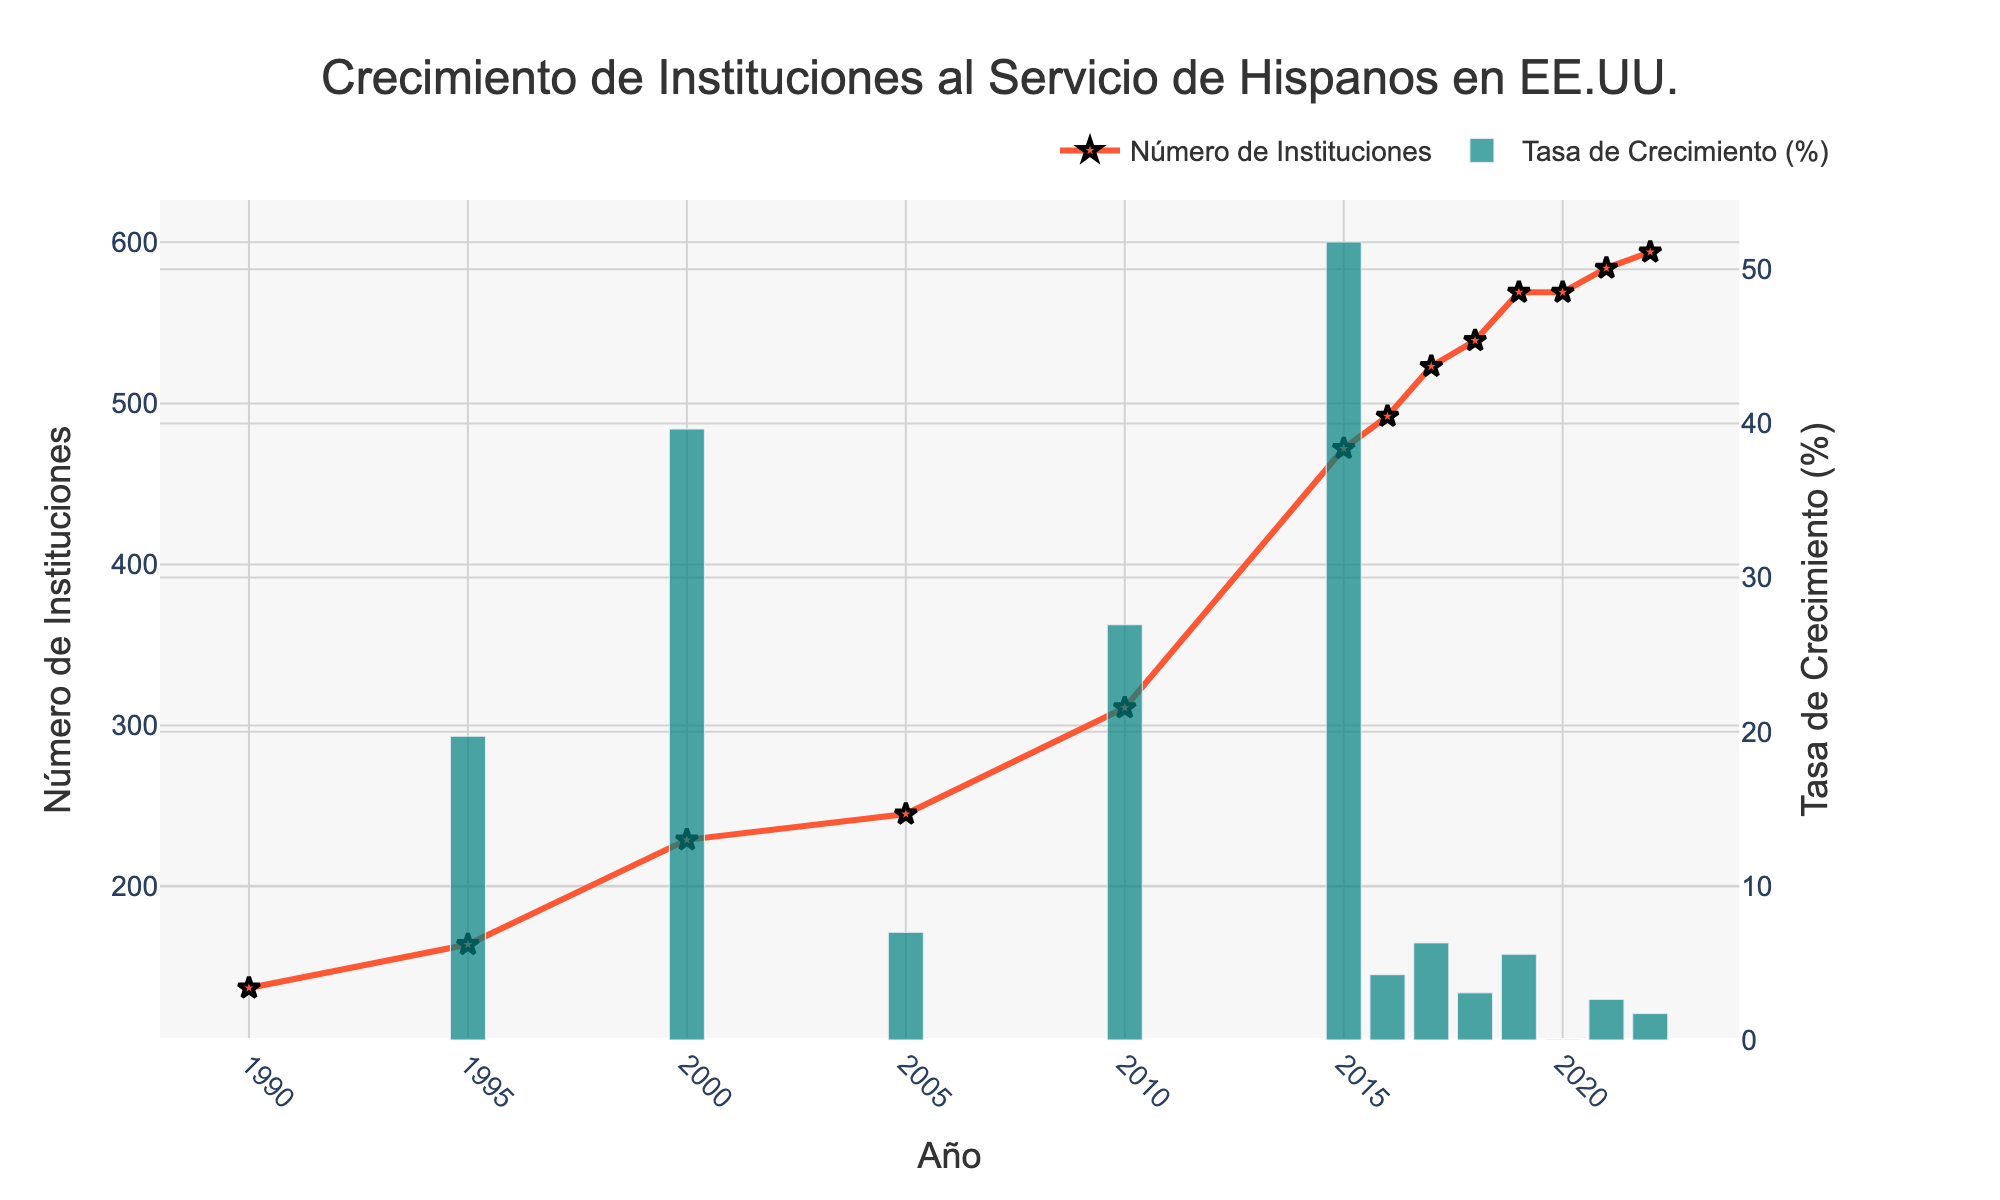number of Hispanic-Serving Institutions? From the chart, examine the positions of the line and dots between the two years mentioned. In 1995, the number of institutions is at 164, and in 2015, it's at 472.
Answer: 472 is greater than 164 Which year shows the highest growth rate in Hispanic-Serving Institutions? Look at the height of the bars in the chart. The year with the tallest bar indicates the highest growth rate.
Answer: 2010 What is the number of Hispanic-Serving Institutions in 2022 compared to 1990? Look at the positions of the line and markers for the years 1990 and 2022. In 1990, there were 137 institutions, and in 2022, there were 594.
Answer: 594 is greater than 137 Between which two consecutive years did the number of Hispanic-Serving Institutions remain the same? Examine the line connecting the markers for each year; the flat part of the line indicates no change.
Answer: 2019 and 2020 What visual element is used to represent the number of Hispanic-Serving Institutions over the years? Identify the type and characteristics of the primary visual elements that represent the data in the chart.
Answer: Lines and markers What is the approximate growth rate in 1995? Look at the bar corresponding to 1995 for the approximate height, representing the growth rate.
Answer: Around 20% How has the trend of the number of Hispanic-Serving Institutions changed from 2000 to 2010? Follow the line and markers in the chart from 2000 to 2010 to observe the trend.
Answer: Upward trend Which year shows a sudden increase in the number of institutions after a relatively flat period? Look for years where the angle of the line sharply increases after being relatively flat.
Answer: 2015 What visual pattern suggests the overall trend in the number of Hispanic-Serving Institutions from 1990 to 2022? Observe the general direction and slope of the line and markers throughout the years.
Answer: Increasing trend 